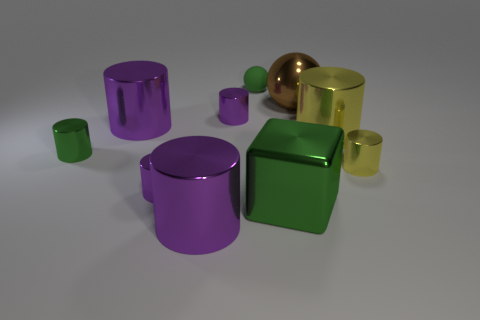Subtract all purple cylinders. How many were subtracted if there are1purple cylinders left? 3 Subtract all green balls. How many purple cylinders are left? 4 Subtract all yellow shiny cylinders. How many cylinders are left? 5 Subtract all green cylinders. How many cylinders are left? 6 Subtract all red cylinders. Subtract all cyan blocks. How many cylinders are left? 7 Subtract all cylinders. How many objects are left? 3 Subtract all large brown metal things. Subtract all green metal things. How many objects are left? 7 Add 4 large cylinders. How many large cylinders are left? 7 Add 10 rubber cylinders. How many rubber cylinders exist? 10 Subtract 1 green cylinders. How many objects are left? 9 